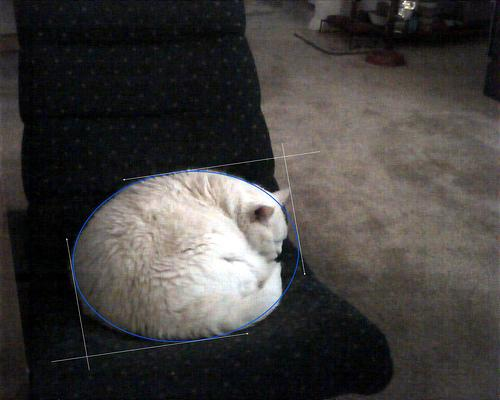What type of floor covering is present under the stool in the image? There is a small carpet under the stool. Kindly describe the circle and line pattern shown in the image. A blue circle is drawn around the white cat, and there are white lines surrounding the blue circle. What color is the cat in the picture, and what position is it in? The cat is white and is curled up in a sleeping position. How many food dishes are present in the image, and what animals are they for? There are two food dishes: a cat food dish elevated off the floor and a dog food dish on the floor. Can you tell me what dishes the cat has nearby and where they are placed? There is a water dish on the floor in the background, and a food dish elevated off the floor, sitting on a mat. Identify the primary element in the image and mention its activity. A white cat is the primary subject, and it is curled up in a ball, sleeping on a chair. Describe the position of the chair and carpet within the room. The chair sits on the carpet, which is on the ground, and the chair is close to a wall while the carpet lies next to it. Explain the appearance of the carpet in the image. The carpet is a blend of tan and gray shades with a beige overtone, and it is situated next to the chair. Provide a detailed description of the cat's ears, tail, and face. The cat's ears are triangular and pointy, its tail is big and white, wrapped around its body, and its face appears sleepy. Can you describe the chair on which the white cat is relaxing? The chair is a dark-colored, padded office chair with a polka-dotted pattern and a narrow design. 